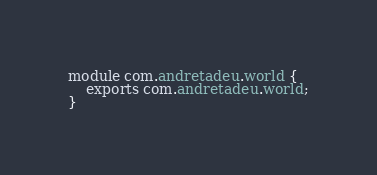<code> <loc_0><loc_0><loc_500><loc_500><_Java_>module com.andretadeu.world {
    exports com.andretadeu.world;
}</code> 